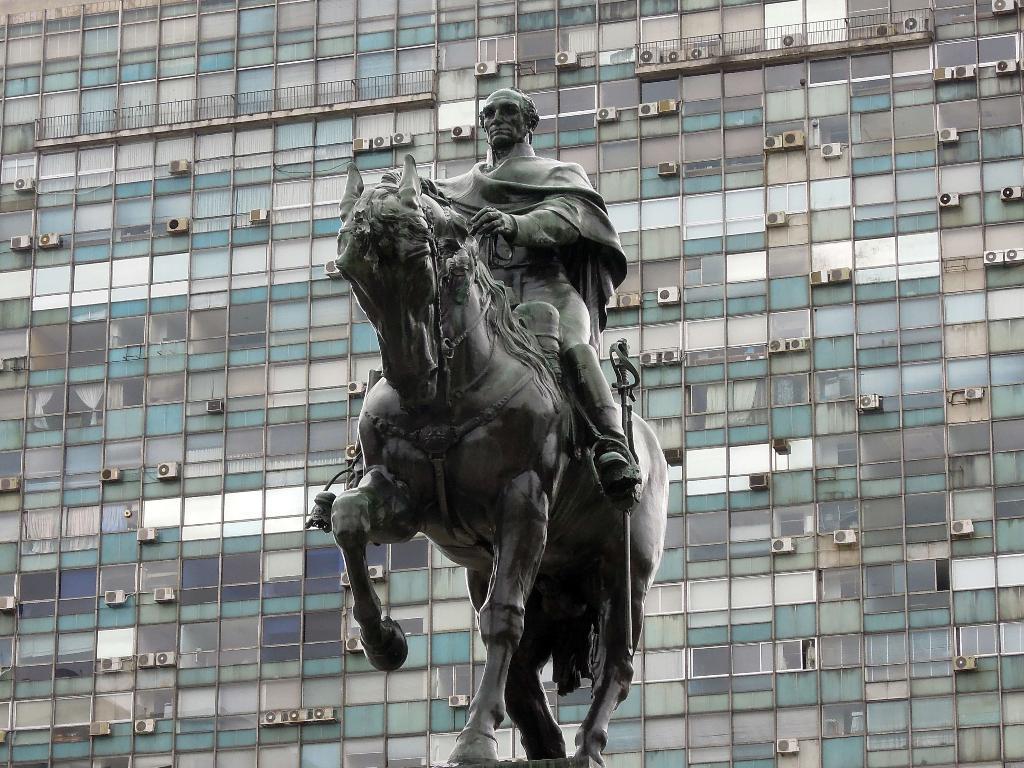Could you give a brief overview of what you see in this image? In this image i can see a statue of a person who is sitting on a horse and at the background of the image there is a building. 